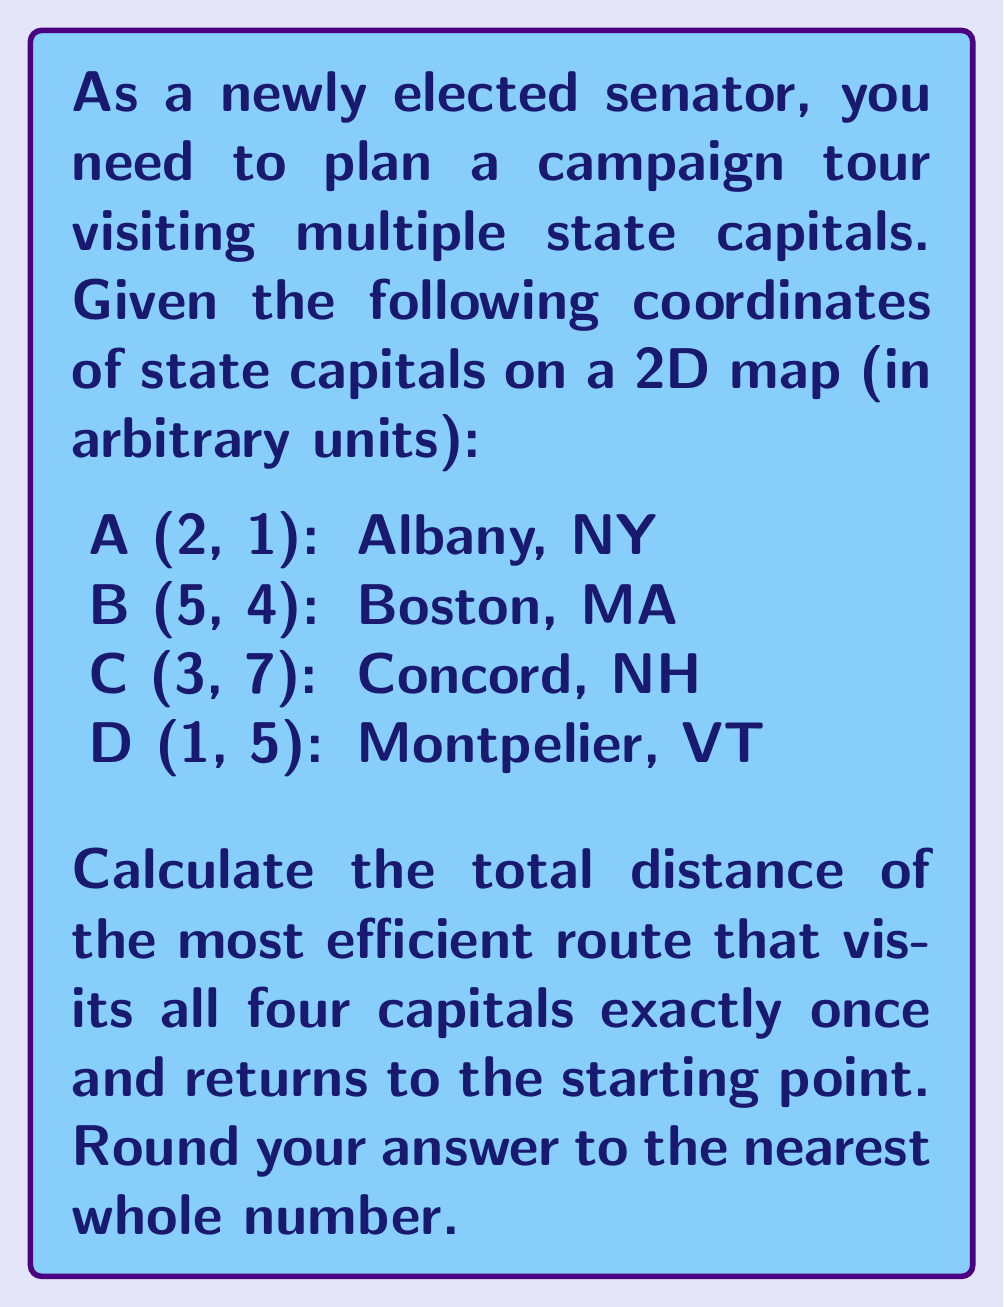Could you help me with this problem? To solve this problem, we need to use the concept of the Traveling Salesman Problem (TSP) and the distance formula in a 2D coordinate system.

1. First, let's calculate the distances between all pairs of cities using the distance formula:
   $$d = \sqrt{(x_2 - x_1)^2 + (y_2 - y_1)^2}$$

   AB = $\sqrt{(5-2)^2 + (4-1)^2} = \sqrt{34} \approx 5.83$
   AC = $\sqrt{(3-2)^2 + (7-1)^2} = \sqrt{37} \approx 6.08$
   AD = $\sqrt{(1-2)^2 + (5-1)^2} = \sqrt{17} \approx 4.12$
   BC = $\sqrt{(3-5)^2 + (7-4)^2} = \sqrt{13} \approx 3.61$
   BD = $\sqrt{(1-5)^2 + (5-4)^2} = \sqrt{17} \approx 4.12$
   CD = $\sqrt{(1-3)^2 + (5-7)^2} = \sqrt{8} \approx 2.83$

2. Now, we need to find the shortest route that visits all cities once and returns to the starting point. For four cities, there are 3! = 6 possible routes:

   ABCDA, ABDC A, ACBDA, ACDBA, ADBCA, ADCBA

3. Let's calculate the total distance for each route:

   ABCDA: 5.83 + 3.61 + 2.83 + 4.12 = 16.39
   ABDCA: 5.83 + 4.12 + 2.83 + 6.08 = 18.86
   ACBDA: 6.08 + 3.61 + 4.12 + 4.12 = 17.93
   ACDBA: 6.08 + 2.83 + 4.12 + 5.83 = 18.86
   ADBCA: 4.12 + 4.12 + 3.61 + 6.08 = 17.93
   ADCBA: 4.12 + 2.83 + 3.61 + 5.83 = 16.39

4. The shortest routes are ABCDA and ADCBA, both with a total distance of 16.39 units.

5. Rounding to the nearest whole number: 16.39 ≈ 16
Answer: 16 units 